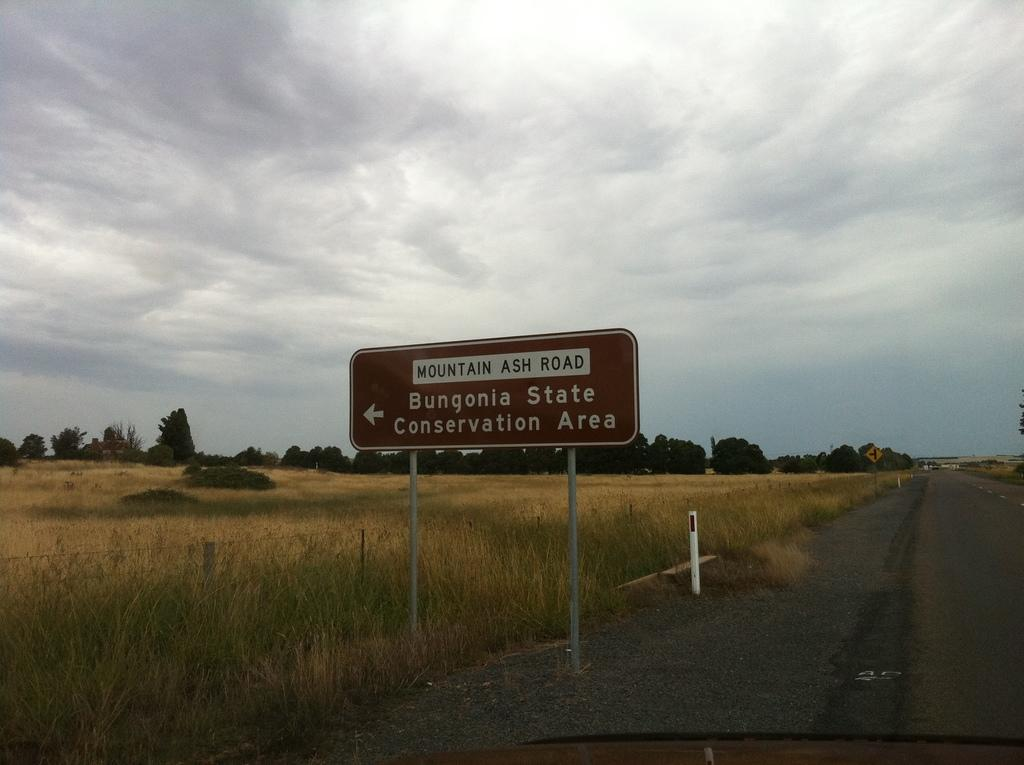<image>
Create a compact narrative representing the image presented. Mountain Ash Road sign with Bungonia State Conservation Area. 